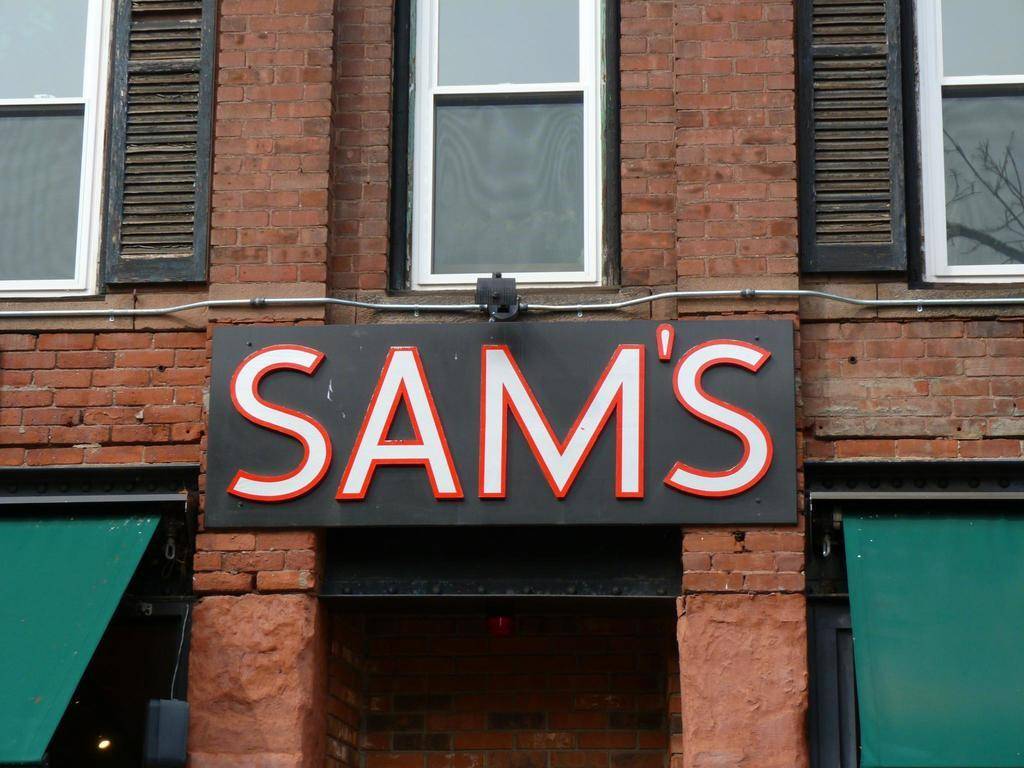<image>
Provide a brief description of the given image. A storefront made of brick with a black sign that says sam's. 